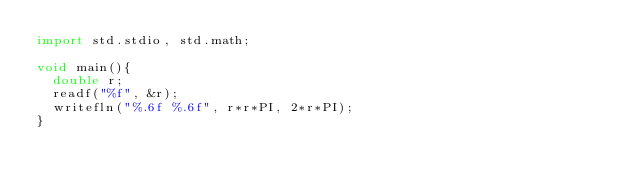<code> <loc_0><loc_0><loc_500><loc_500><_D_>import std.stdio, std.math;

void main(){
	double r;
	readf("%f", &r);
	writefln("%.6f %.6f", r*r*PI, 2*r*PI);
}</code> 